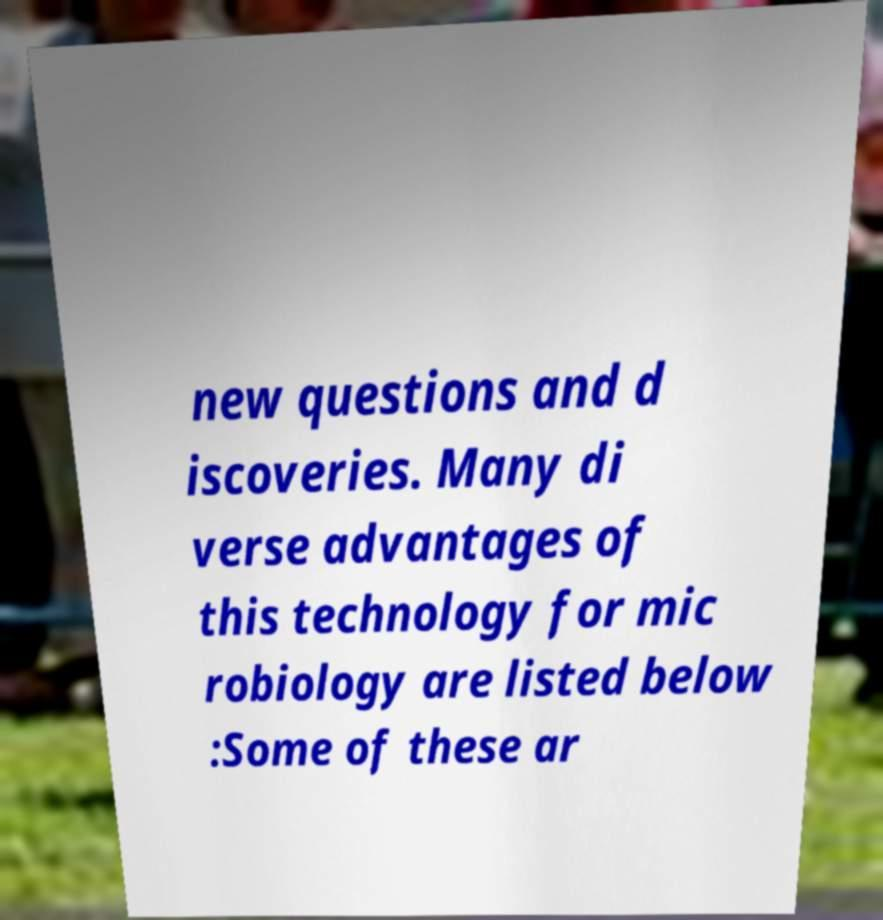Please identify and transcribe the text found in this image. new questions and d iscoveries. Many di verse advantages of this technology for mic robiology are listed below :Some of these ar 